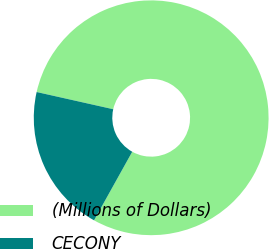<chart> <loc_0><loc_0><loc_500><loc_500><pie_chart><fcel>(Millions of Dollars)<fcel>CECONY<nl><fcel>79.57%<fcel>20.43%<nl></chart> 